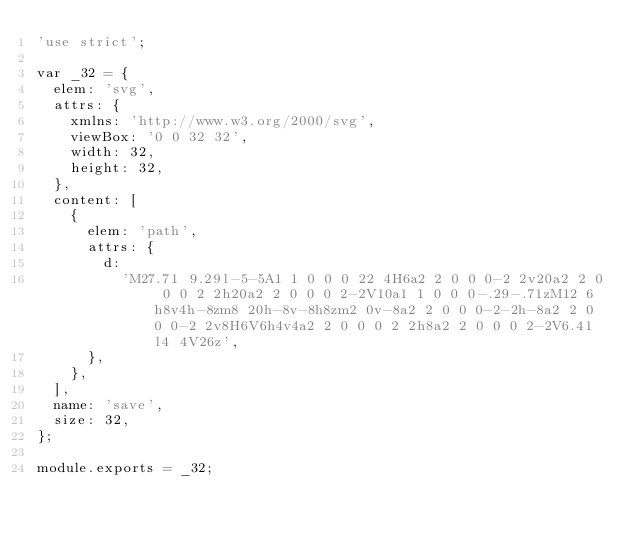<code> <loc_0><loc_0><loc_500><loc_500><_JavaScript_>'use strict';

var _32 = {
  elem: 'svg',
  attrs: {
    xmlns: 'http://www.w3.org/2000/svg',
    viewBox: '0 0 32 32',
    width: 32,
    height: 32,
  },
  content: [
    {
      elem: 'path',
      attrs: {
        d:
          'M27.71 9.29l-5-5A1 1 0 0 0 22 4H6a2 2 0 0 0-2 2v20a2 2 0 0 0 2 2h20a2 2 0 0 0 2-2V10a1 1 0 0 0-.29-.71zM12 6h8v4h-8zm8 20h-8v-8h8zm2 0v-8a2 2 0 0 0-2-2h-8a2 2 0 0 0-2 2v8H6V6h4v4a2 2 0 0 0 2 2h8a2 2 0 0 0 2-2V6.41l4 4V26z',
      },
    },
  ],
  name: 'save',
  size: 32,
};

module.exports = _32;
</code> 